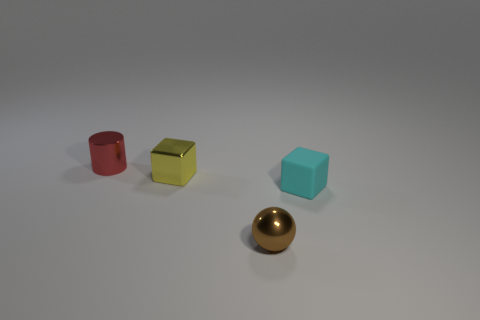Add 3 tiny cyan rubber cubes. How many objects exist? 7 Subtract all cyan blocks. How many blocks are left? 1 Subtract all cylinders. How many objects are left? 3 Subtract all metal blocks. Subtract all brown balls. How many objects are left? 2 Add 2 tiny metal spheres. How many tiny metal spheres are left? 3 Add 1 small shiny things. How many small shiny things exist? 4 Subtract 1 red cylinders. How many objects are left? 3 